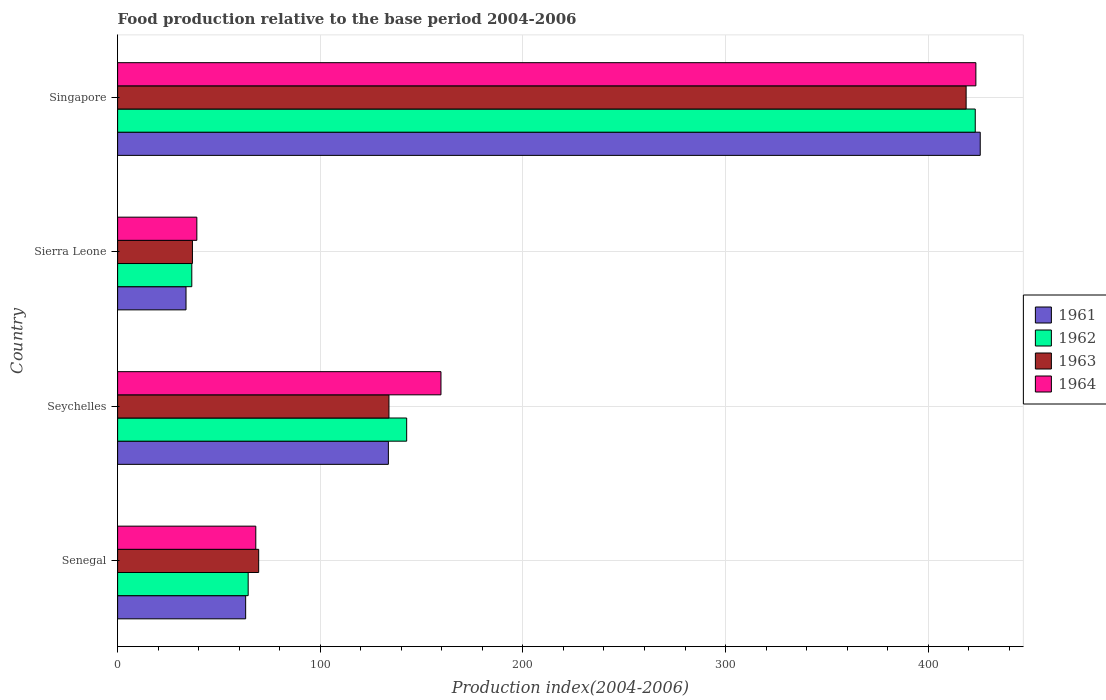How many groups of bars are there?
Offer a terse response. 4. Are the number of bars on each tick of the Y-axis equal?
Offer a terse response. Yes. What is the label of the 1st group of bars from the top?
Make the answer very short. Singapore. What is the food production index in 1963 in Seychelles?
Ensure brevity in your answer.  133.9. Across all countries, what is the maximum food production index in 1963?
Make the answer very short. 418.73. Across all countries, what is the minimum food production index in 1963?
Make the answer very short. 36.93. In which country was the food production index in 1962 maximum?
Provide a short and direct response. Singapore. In which country was the food production index in 1964 minimum?
Make the answer very short. Sierra Leone. What is the total food production index in 1963 in the graph?
Your answer should be very brief. 659.17. What is the difference between the food production index in 1961 in Seychelles and that in Sierra Leone?
Offer a terse response. 99.86. What is the difference between the food production index in 1961 in Sierra Leone and the food production index in 1964 in Seychelles?
Make the answer very short. -125.81. What is the average food production index in 1963 per country?
Your answer should be very brief. 164.79. What is the difference between the food production index in 1961 and food production index in 1963 in Sierra Leone?
Provide a succinct answer. -3.17. What is the ratio of the food production index in 1962 in Seychelles to that in Singapore?
Provide a succinct answer. 0.34. Is the difference between the food production index in 1961 in Senegal and Singapore greater than the difference between the food production index in 1963 in Senegal and Singapore?
Your response must be concise. No. What is the difference between the highest and the second highest food production index in 1961?
Your response must be concise. 292.07. What is the difference between the highest and the lowest food production index in 1964?
Make the answer very short. 384.44. In how many countries, is the food production index in 1963 greater than the average food production index in 1963 taken over all countries?
Your answer should be very brief. 1. Is it the case that in every country, the sum of the food production index in 1962 and food production index in 1963 is greater than the sum of food production index in 1964 and food production index in 1961?
Give a very brief answer. No. What does the 3rd bar from the top in Singapore represents?
Give a very brief answer. 1962. What does the 1st bar from the bottom in Sierra Leone represents?
Provide a short and direct response. 1961. How many bars are there?
Your response must be concise. 16. Are all the bars in the graph horizontal?
Make the answer very short. Yes. How many legend labels are there?
Ensure brevity in your answer.  4. How are the legend labels stacked?
Provide a succinct answer. Vertical. What is the title of the graph?
Provide a succinct answer. Food production relative to the base period 2004-2006. What is the label or title of the X-axis?
Provide a succinct answer. Production index(2004-2006). What is the label or title of the Y-axis?
Offer a terse response. Country. What is the Production index(2004-2006) in 1961 in Senegal?
Your answer should be very brief. 63.19. What is the Production index(2004-2006) in 1962 in Senegal?
Ensure brevity in your answer.  64.43. What is the Production index(2004-2006) in 1963 in Senegal?
Your response must be concise. 69.61. What is the Production index(2004-2006) in 1964 in Senegal?
Make the answer very short. 68.19. What is the Production index(2004-2006) in 1961 in Seychelles?
Offer a very short reply. 133.62. What is the Production index(2004-2006) of 1962 in Seychelles?
Provide a succinct answer. 142.65. What is the Production index(2004-2006) of 1963 in Seychelles?
Provide a succinct answer. 133.9. What is the Production index(2004-2006) of 1964 in Seychelles?
Keep it short and to the point. 159.57. What is the Production index(2004-2006) of 1961 in Sierra Leone?
Ensure brevity in your answer.  33.76. What is the Production index(2004-2006) in 1962 in Sierra Leone?
Provide a short and direct response. 36.61. What is the Production index(2004-2006) in 1963 in Sierra Leone?
Provide a succinct answer. 36.93. What is the Production index(2004-2006) in 1964 in Sierra Leone?
Ensure brevity in your answer.  39.1. What is the Production index(2004-2006) in 1961 in Singapore?
Provide a short and direct response. 425.69. What is the Production index(2004-2006) in 1962 in Singapore?
Offer a terse response. 423.23. What is the Production index(2004-2006) of 1963 in Singapore?
Ensure brevity in your answer.  418.73. What is the Production index(2004-2006) in 1964 in Singapore?
Your response must be concise. 423.54. Across all countries, what is the maximum Production index(2004-2006) in 1961?
Ensure brevity in your answer.  425.69. Across all countries, what is the maximum Production index(2004-2006) in 1962?
Keep it short and to the point. 423.23. Across all countries, what is the maximum Production index(2004-2006) in 1963?
Offer a very short reply. 418.73. Across all countries, what is the maximum Production index(2004-2006) in 1964?
Your answer should be compact. 423.54. Across all countries, what is the minimum Production index(2004-2006) in 1961?
Provide a succinct answer. 33.76. Across all countries, what is the minimum Production index(2004-2006) of 1962?
Give a very brief answer. 36.61. Across all countries, what is the minimum Production index(2004-2006) in 1963?
Give a very brief answer. 36.93. Across all countries, what is the minimum Production index(2004-2006) of 1964?
Offer a terse response. 39.1. What is the total Production index(2004-2006) in 1961 in the graph?
Your response must be concise. 656.26. What is the total Production index(2004-2006) of 1962 in the graph?
Provide a succinct answer. 666.92. What is the total Production index(2004-2006) of 1963 in the graph?
Your response must be concise. 659.17. What is the total Production index(2004-2006) of 1964 in the graph?
Provide a short and direct response. 690.4. What is the difference between the Production index(2004-2006) in 1961 in Senegal and that in Seychelles?
Offer a terse response. -70.43. What is the difference between the Production index(2004-2006) of 1962 in Senegal and that in Seychelles?
Give a very brief answer. -78.22. What is the difference between the Production index(2004-2006) of 1963 in Senegal and that in Seychelles?
Ensure brevity in your answer.  -64.29. What is the difference between the Production index(2004-2006) in 1964 in Senegal and that in Seychelles?
Your answer should be very brief. -91.38. What is the difference between the Production index(2004-2006) in 1961 in Senegal and that in Sierra Leone?
Provide a short and direct response. 29.43. What is the difference between the Production index(2004-2006) in 1962 in Senegal and that in Sierra Leone?
Offer a very short reply. 27.82. What is the difference between the Production index(2004-2006) in 1963 in Senegal and that in Sierra Leone?
Your answer should be compact. 32.68. What is the difference between the Production index(2004-2006) in 1964 in Senegal and that in Sierra Leone?
Your answer should be very brief. 29.09. What is the difference between the Production index(2004-2006) in 1961 in Senegal and that in Singapore?
Your answer should be compact. -362.5. What is the difference between the Production index(2004-2006) of 1962 in Senegal and that in Singapore?
Your answer should be compact. -358.8. What is the difference between the Production index(2004-2006) of 1963 in Senegal and that in Singapore?
Keep it short and to the point. -349.12. What is the difference between the Production index(2004-2006) in 1964 in Senegal and that in Singapore?
Your response must be concise. -355.35. What is the difference between the Production index(2004-2006) of 1961 in Seychelles and that in Sierra Leone?
Offer a very short reply. 99.86. What is the difference between the Production index(2004-2006) of 1962 in Seychelles and that in Sierra Leone?
Offer a terse response. 106.04. What is the difference between the Production index(2004-2006) of 1963 in Seychelles and that in Sierra Leone?
Your answer should be very brief. 96.97. What is the difference between the Production index(2004-2006) in 1964 in Seychelles and that in Sierra Leone?
Your answer should be very brief. 120.47. What is the difference between the Production index(2004-2006) in 1961 in Seychelles and that in Singapore?
Offer a very short reply. -292.07. What is the difference between the Production index(2004-2006) of 1962 in Seychelles and that in Singapore?
Your answer should be very brief. -280.58. What is the difference between the Production index(2004-2006) of 1963 in Seychelles and that in Singapore?
Keep it short and to the point. -284.83. What is the difference between the Production index(2004-2006) of 1964 in Seychelles and that in Singapore?
Keep it short and to the point. -263.97. What is the difference between the Production index(2004-2006) of 1961 in Sierra Leone and that in Singapore?
Your answer should be compact. -391.93. What is the difference between the Production index(2004-2006) in 1962 in Sierra Leone and that in Singapore?
Ensure brevity in your answer.  -386.62. What is the difference between the Production index(2004-2006) in 1963 in Sierra Leone and that in Singapore?
Provide a succinct answer. -381.8. What is the difference between the Production index(2004-2006) in 1964 in Sierra Leone and that in Singapore?
Ensure brevity in your answer.  -384.44. What is the difference between the Production index(2004-2006) of 1961 in Senegal and the Production index(2004-2006) of 1962 in Seychelles?
Keep it short and to the point. -79.46. What is the difference between the Production index(2004-2006) in 1961 in Senegal and the Production index(2004-2006) in 1963 in Seychelles?
Ensure brevity in your answer.  -70.71. What is the difference between the Production index(2004-2006) in 1961 in Senegal and the Production index(2004-2006) in 1964 in Seychelles?
Your answer should be compact. -96.38. What is the difference between the Production index(2004-2006) in 1962 in Senegal and the Production index(2004-2006) in 1963 in Seychelles?
Ensure brevity in your answer.  -69.47. What is the difference between the Production index(2004-2006) of 1962 in Senegal and the Production index(2004-2006) of 1964 in Seychelles?
Your answer should be compact. -95.14. What is the difference between the Production index(2004-2006) in 1963 in Senegal and the Production index(2004-2006) in 1964 in Seychelles?
Provide a short and direct response. -89.96. What is the difference between the Production index(2004-2006) in 1961 in Senegal and the Production index(2004-2006) in 1962 in Sierra Leone?
Your answer should be very brief. 26.58. What is the difference between the Production index(2004-2006) of 1961 in Senegal and the Production index(2004-2006) of 1963 in Sierra Leone?
Your answer should be very brief. 26.26. What is the difference between the Production index(2004-2006) of 1961 in Senegal and the Production index(2004-2006) of 1964 in Sierra Leone?
Your answer should be compact. 24.09. What is the difference between the Production index(2004-2006) in 1962 in Senegal and the Production index(2004-2006) in 1964 in Sierra Leone?
Provide a short and direct response. 25.33. What is the difference between the Production index(2004-2006) of 1963 in Senegal and the Production index(2004-2006) of 1964 in Sierra Leone?
Your answer should be very brief. 30.51. What is the difference between the Production index(2004-2006) of 1961 in Senegal and the Production index(2004-2006) of 1962 in Singapore?
Your answer should be very brief. -360.04. What is the difference between the Production index(2004-2006) in 1961 in Senegal and the Production index(2004-2006) in 1963 in Singapore?
Provide a succinct answer. -355.54. What is the difference between the Production index(2004-2006) in 1961 in Senegal and the Production index(2004-2006) in 1964 in Singapore?
Give a very brief answer. -360.35. What is the difference between the Production index(2004-2006) of 1962 in Senegal and the Production index(2004-2006) of 1963 in Singapore?
Provide a short and direct response. -354.3. What is the difference between the Production index(2004-2006) in 1962 in Senegal and the Production index(2004-2006) in 1964 in Singapore?
Offer a very short reply. -359.11. What is the difference between the Production index(2004-2006) of 1963 in Senegal and the Production index(2004-2006) of 1964 in Singapore?
Your response must be concise. -353.93. What is the difference between the Production index(2004-2006) of 1961 in Seychelles and the Production index(2004-2006) of 1962 in Sierra Leone?
Provide a succinct answer. 97.01. What is the difference between the Production index(2004-2006) of 1961 in Seychelles and the Production index(2004-2006) of 1963 in Sierra Leone?
Make the answer very short. 96.69. What is the difference between the Production index(2004-2006) in 1961 in Seychelles and the Production index(2004-2006) in 1964 in Sierra Leone?
Keep it short and to the point. 94.52. What is the difference between the Production index(2004-2006) of 1962 in Seychelles and the Production index(2004-2006) of 1963 in Sierra Leone?
Provide a succinct answer. 105.72. What is the difference between the Production index(2004-2006) of 1962 in Seychelles and the Production index(2004-2006) of 1964 in Sierra Leone?
Make the answer very short. 103.55. What is the difference between the Production index(2004-2006) of 1963 in Seychelles and the Production index(2004-2006) of 1964 in Sierra Leone?
Keep it short and to the point. 94.8. What is the difference between the Production index(2004-2006) of 1961 in Seychelles and the Production index(2004-2006) of 1962 in Singapore?
Make the answer very short. -289.61. What is the difference between the Production index(2004-2006) in 1961 in Seychelles and the Production index(2004-2006) in 1963 in Singapore?
Keep it short and to the point. -285.11. What is the difference between the Production index(2004-2006) of 1961 in Seychelles and the Production index(2004-2006) of 1964 in Singapore?
Your answer should be very brief. -289.92. What is the difference between the Production index(2004-2006) in 1962 in Seychelles and the Production index(2004-2006) in 1963 in Singapore?
Give a very brief answer. -276.08. What is the difference between the Production index(2004-2006) of 1962 in Seychelles and the Production index(2004-2006) of 1964 in Singapore?
Your response must be concise. -280.89. What is the difference between the Production index(2004-2006) in 1963 in Seychelles and the Production index(2004-2006) in 1964 in Singapore?
Ensure brevity in your answer.  -289.64. What is the difference between the Production index(2004-2006) of 1961 in Sierra Leone and the Production index(2004-2006) of 1962 in Singapore?
Offer a very short reply. -389.47. What is the difference between the Production index(2004-2006) in 1961 in Sierra Leone and the Production index(2004-2006) in 1963 in Singapore?
Ensure brevity in your answer.  -384.97. What is the difference between the Production index(2004-2006) in 1961 in Sierra Leone and the Production index(2004-2006) in 1964 in Singapore?
Your response must be concise. -389.78. What is the difference between the Production index(2004-2006) of 1962 in Sierra Leone and the Production index(2004-2006) of 1963 in Singapore?
Provide a succinct answer. -382.12. What is the difference between the Production index(2004-2006) of 1962 in Sierra Leone and the Production index(2004-2006) of 1964 in Singapore?
Make the answer very short. -386.93. What is the difference between the Production index(2004-2006) of 1963 in Sierra Leone and the Production index(2004-2006) of 1964 in Singapore?
Give a very brief answer. -386.61. What is the average Production index(2004-2006) in 1961 per country?
Provide a short and direct response. 164.06. What is the average Production index(2004-2006) in 1962 per country?
Keep it short and to the point. 166.73. What is the average Production index(2004-2006) in 1963 per country?
Make the answer very short. 164.79. What is the average Production index(2004-2006) of 1964 per country?
Keep it short and to the point. 172.6. What is the difference between the Production index(2004-2006) in 1961 and Production index(2004-2006) in 1962 in Senegal?
Provide a succinct answer. -1.24. What is the difference between the Production index(2004-2006) of 1961 and Production index(2004-2006) of 1963 in Senegal?
Give a very brief answer. -6.42. What is the difference between the Production index(2004-2006) of 1962 and Production index(2004-2006) of 1963 in Senegal?
Offer a very short reply. -5.18. What is the difference between the Production index(2004-2006) of 1962 and Production index(2004-2006) of 1964 in Senegal?
Offer a very short reply. -3.76. What is the difference between the Production index(2004-2006) in 1963 and Production index(2004-2006) in 1964 in Senegal?
Keep it short and to the point. 1.42. What is the difference between the Production index(2004-2006) in 1961 and Production index(2004-2006) in 1962 in Seychelles?
Your answer should be very brief. -9.03. What is the difference between the Production index(2004-2006) in 1961 and Production index(2004-2006) in 1963 in Seychelles?
Offer a terse response. -0.28. What is the difference between the Production index(2004-2006) in 1961 and Production index(2004-2006) in 1964 in Seychelles?
Offer a very short reply. -25.95. What is the difference between the Production index(2004-2006) in 1962 and Production index(2004-2006) in 1963 in Seychelles?
Keep it short and to the point. 8.75. What is the difference between the Production index(2004-2006) in 1962 and Production index(2004-2006) in 1964 in Seychelles?
Your answer should be very brief. -16.92. What is the difference between the Production index(2004-2006) in 1963 and Production index(2004-2006) in 1964 in Seychelles?
Give a very brief answer. -25.67. What is the difference between the Production index(2004-2006) of 1961 and Production index(2004-2006) of 1962 in Sierra Leone?
Give a very brief answer. -2.85. What is the difference between the Production index(2004-2006) of 1961 and Production index(2004-2006) of 1963 in Sierra Leone?
Offer a very short reply. -3.17. What is the difference between the Production index(2004-2006) of 1961 and Production index(2004-2006) of 1964 in Sierra Leone?
Your answer should be very brief. -5.34. What is the difference between the Production index(2004-2006) in 1962 and Production index(2004-2006) in 1963 in Sierra Leone?
Ensure brevity in your answer.  -0.32. What is the difference between the Production index(2004-2006) of 1962 and Production index(2004-2006) of 1964 in Sierra Leone?
Ensure brevity in your answer.  -2.49. What is the difference between the Production index(2004-2006) of 1963 and Production index(2004-2006) of 1964 in Sierra Leone?
Ensure brevity in your answer.  -2.17. What is the difference between the Production index(2004-2006) in 1961 and Production index(2004-2006) in 1962 in Singapore?
Provide a short and direct response. 2.46. What is the difference between the Production index(2004-2006) in 1961 and Production index(2004-2006) in 1963 in Singapore?
Provide a succinct answer. 6.96. What is the difference between the Production index(2004-2006) in 1961 and Production index(2004-2006) in 1964 in Singapore?
Your response must be concise. 2.15. What is the difference between the Production index(2004-2006) of 1962 and Production index(2004-2006) of 1964 in Singapore?
Make the answer very short. -0.31. What is the difference between the Production index(2004-2006) of 1963 and Production index(2004-2006) of 1964 in Singapore?
Your answer should be compact. -4.81. What is the ratio of the Production index(2004-2006) of 1961 in Senegal to that in Seychelles?
Give a very brief answer. 0.47. What is the ratio of the Production index(2004-2006) in 1962 in Senegal to that in Seychelles?
Make the answer very short. 0.45. What is the ratio of the Production index(2004-2006) of 1963 in Senegal to that in Seychelles?
Provide a succinct answer. 0.52. What is the ratio of the Production index(2004-2006) of 1964 in Senegal to that in Seychelles?
Ensure brevity in your answer.  0.43. What is the ratio of the Production index(2004-2006) of 1961 in Senegal to that in Sierra Leone?
Your answer should be compact. 1.87. What is the ratio of the Production index(2004-2006) of 1962 in Senegal to that in Sierra Leone?
Your response must be concise. 1.76. What is the ratio of the Production index(2004-2006) in 1963 in Senegal to that in Sierra Leone?
Your answer should be very brief. 1.88. What is the ratio of the Production index(2004-2006) in 1964 in Senegal to that in Sierra Leone?
Your answer should be very brief. 1.74. What is the ratio of the Production index(2004-2006) in 1961 in Senegal to that in Singapore?
Offer a very short reply. 0.15. What is the ratio of the Production index(2004-2006) of 1962 in Senegal to that in Singapore?
Your response must be concise. 0.15. What is the ratio of the Production index(2004-2006) of 1963 in Senegal to that in Singapore?
Offer a terse response. 0.17. What is the ratio of the Production index(2004-2006) of 1964 in Senegal to that in Singapore?
Give a very brief answer. 0.16. What is the ratio of the Production index(2004-2006) in 1961 in Seychelles to that in Sierra Leone?
Keep it short and to the point. 3.96. What is the ratio of the Production index(2004-2006) of 1962 in Seychelles to that in Sierra Leone?
Offer a very short reply. 3.9. What is the ratio of the Production index(2004-2006) of 1963 in Seychelles to that in Sierra Leone?
Make the answer very short. 3.63. What is the ratio of the Production index(2004-2006) in 1964 in Seychelles to that in Sierra Leone?
Your answer should be compact. 4.08. What is the ratio of the Production index(2004-2006) in 1961 in Seychelles to that in Singapore?
Ensure brevity in your answer.  0.31. What is the ratio of the Production index(2004-2006) in 1962 in Seychelles to that in Singapore?
Give a very brief answer. 0.34. What is the ratio of the Production index(2004-2006) of 1963 in Seychelles to that in Singapore?
Give a very brief answer. 0.32. What is the ratio of the Production index(2004-2006) of 1964 in Seychelles to that in Singapore?
Offer a terse response. 0.38. What is the ratio of the Production index(2004-2006) of 1961 in Sierra Leone to that in Singapore?
Offer a very short reply. 0.08. What is the ratio of the Production index(2004-2006) in 1962 in Sierra Leone to that in Singapore?
Ensure brevity in your answer.  0.09. What is the ratio of the Production index(2004-2006) of 1963 in Sierra Leone to that in Singapore?
Provide a short and direct response. 0.09. What is the ratio of the Production index(2004-2006) in 1964 in Sierra Leone to that in Singapore?
Make the answer very short. 0.09. What is the difference between the highest and the second highest Production index(2004-2006) of 1961?
Make the answer very short. 292.07. What is the difference between the highest and the second highest Production index(2004-2006) in 1962?
Offer a terse response. 280.58. What is the difference between the highest and the second highest Production index(2004-2006) of 1963?
Your answer should be very brief. 284.83. What is the difference between the highest and the second highest Production index(2004-2006) in 1964?
Give a very brief answer. 263.97. What is the difference between the highest and the lowest Production index(2004-2006) in 1961?
Provide a succinct answer. 391.93. What is the difference between the highest and the lowest Production index(2004-2006) of 1962?
Provide a succinct answer. 386.62. What is the difference between the highest and the lowest Production index(2004-2006) in 1963?
Offer a terse response. 381.8. What is the difference between the highest and the lowest Production index(2004-2006) of 1964?
Make the answer very short. 384.44. 